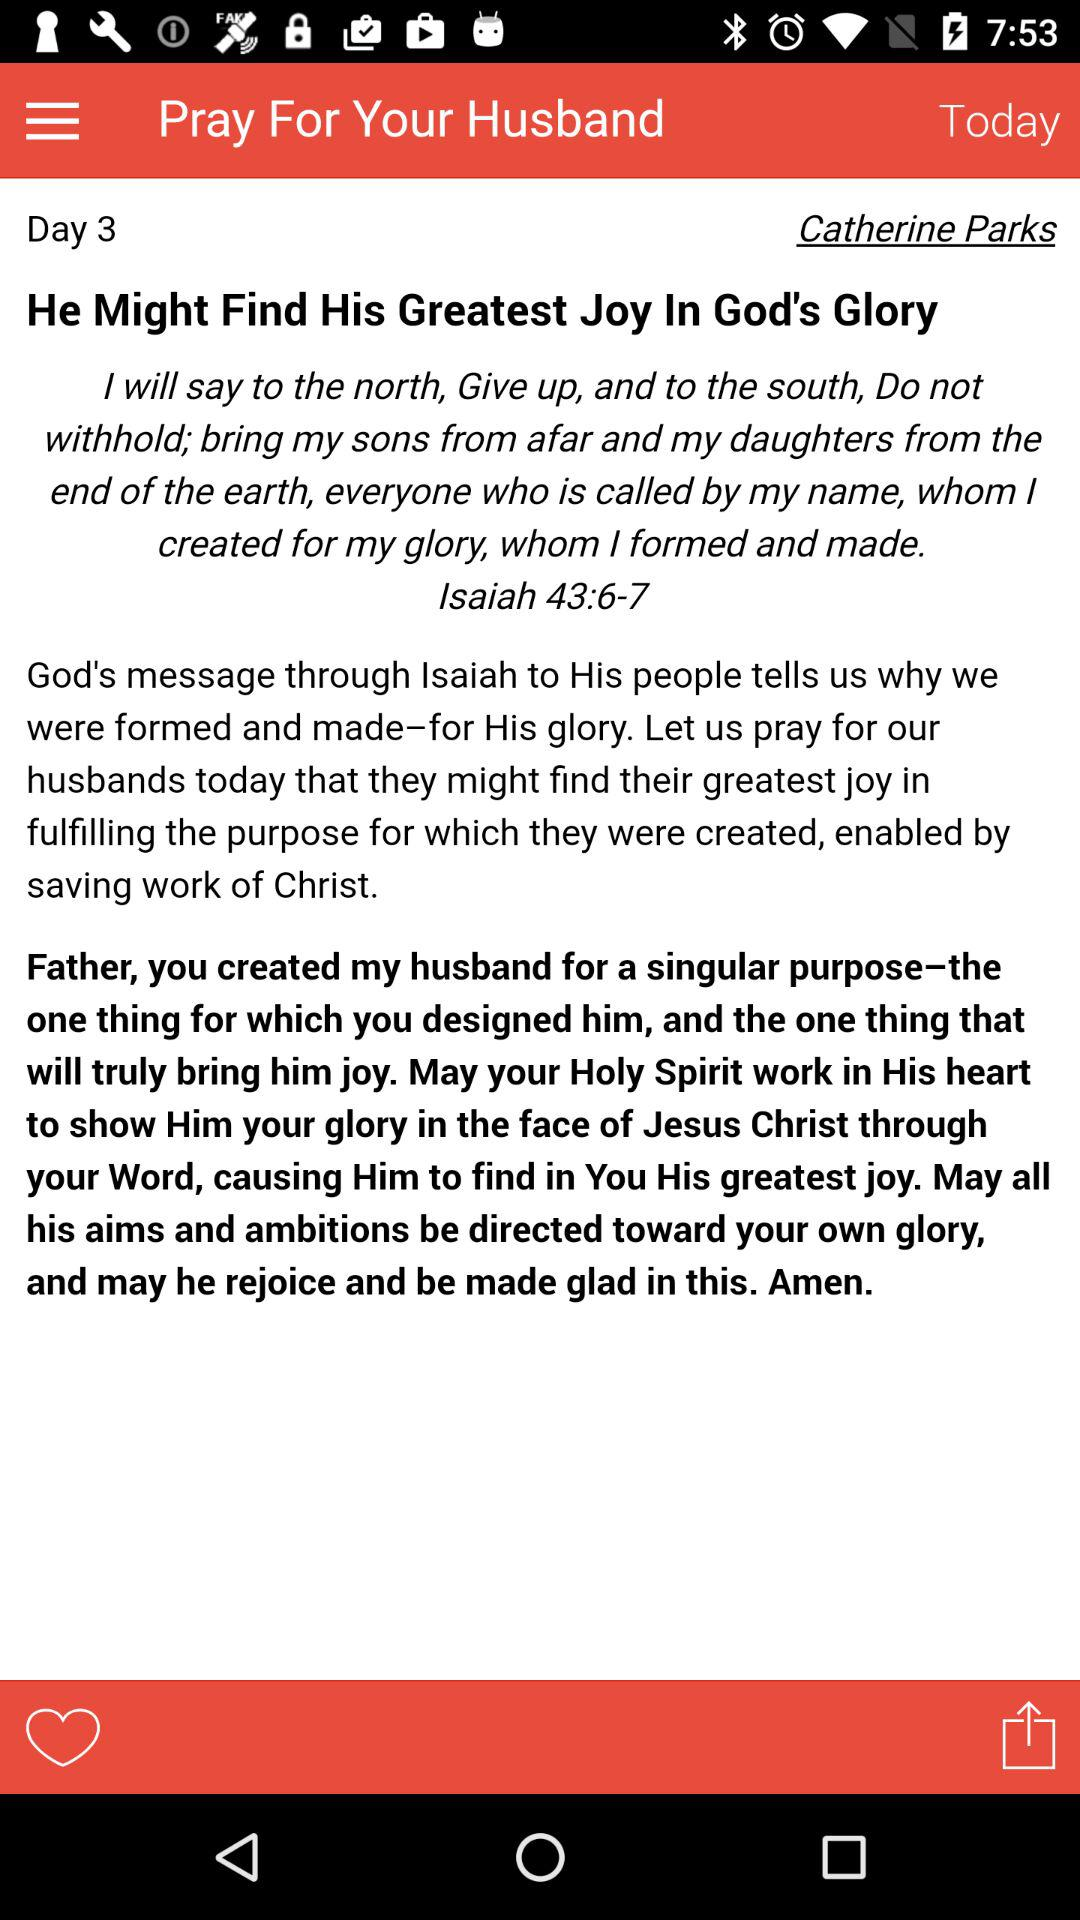What's the name of the author? The name of the author is Catherine Parks. 